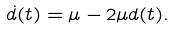Convert formula to latex. <formula><loc_0><loc_0><loc_500><loc_500>\dot { d } ( t ) = \mu - 2 \mu d ( t ) .</formula> 